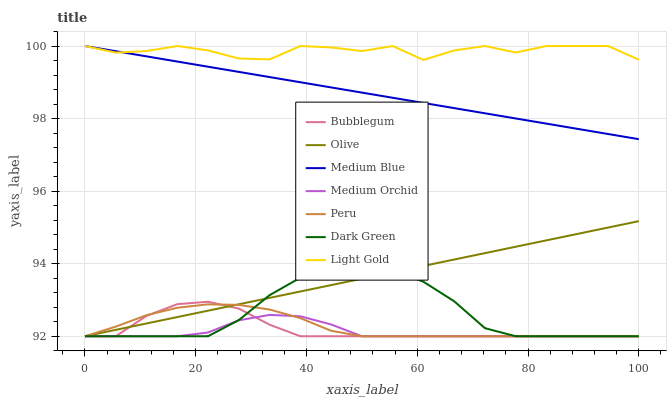Does Medium Orchid have the minimum area under the curve?
Answer yes or no. Yes. Does Medium Blue have the minimum area under the curve?
Answer yes or no. No. Does Medium Blue have the maximum area under the curve?
Answer yes or no. No. Is Medium Blue the smoothest?
Answer yes or no. No. Is Medium Blue the roughest?
Answer yes or no. No. Does Medium Blue have the lowest value?
Answer yes or no. No. Does Bubblegum have the highest value?
Answer yes or no. No. Is Dark Green less than Light Gold?
Answer yes or no. Yes. Is Medium Blue greater than Dark Green?
Answer yes or no. Yes. Does Dark Green intersect Light Gold?
Answer yes or no. No. 